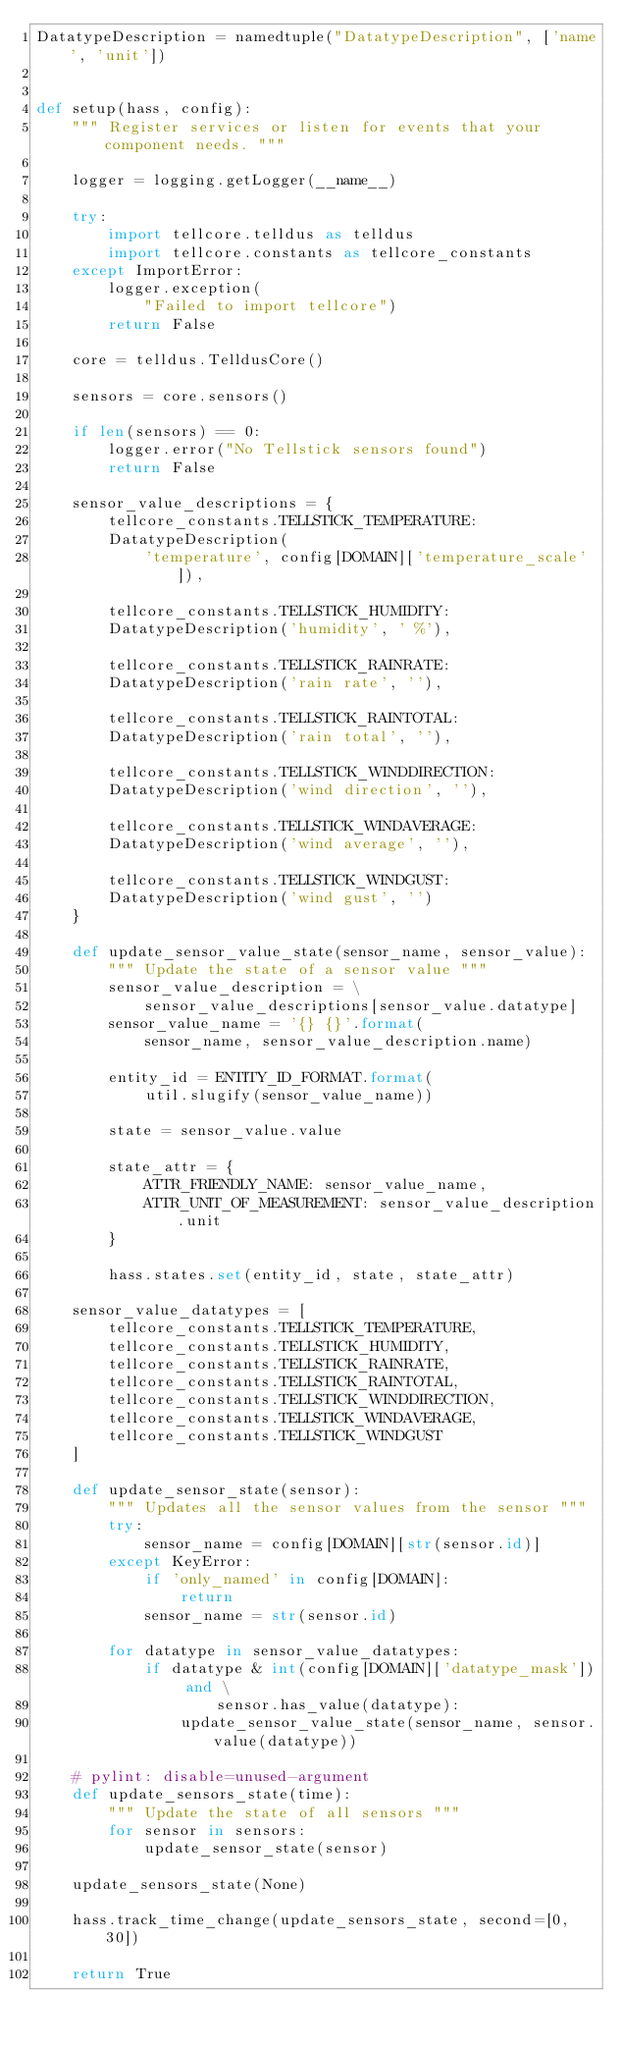<code> <loc_0><loc_0><loc_500><loc_500><_Python_>DatatypeDescription = namedtuple("DatatypeDescription", ['name', 'unit'])


def setup(hass, config):
    """ Register services or listen for events that your component needs. """

    logger = logging.getLogger(__name__)

    try:
        import tellcore.telldus as telldus
        import tellcore.constants as tellcore_constants
    except ImportError:
        logger.exception(
            "Failed to import tellcore")
        return False

    core = telldus.TelldusCore()

    sensors = core.sensors()

    if len(sensors) == 0:
        logger.error("No Tellstick sensors found")
        return False

    sensor_value_descriptions = {
        tellcore_constants.TELLSTICK_TEMPERATURE:
        DatatypeDescription(
            'temperature', config[DOMAIN]['temperature_scale']),

        tellcore_constants.TELLSTICK_HUMIDITY:
        DatatypeDescription('humidity', ' %'),

        tellcore_constants.TELLSTICK_RAINRATE:
        DatatypeDescription('rain rate', ''),

        tellcore_constants.TELLSTICK_RAINTOTAL:
        DatatypeDescription('rain total', ''),

        tellcore_constants.TELLSTICK_WINDDIRECTION:
        DatatypeDescription('wind direction', ''),

        tellcore_constants.TELLSTICK_WINDAVERAGE:
        DatatypeDescription('wind average', ''),

        tellcore_constants.TELLSTICK_WINDGUST:
        DatatypeDescription('wind gust', '')
    }

    def update_sensor_value_state(sensor_name, sensor_value):
        """ Update the state of a sensor value """
        sensor_value_description = \
            sensor_value_descriptions[sensor_value.datatype]
        sensor_value_name = '{} {}'.format(
            sensor_name, sensor_value_description.name)

        entity_id = ENTITY_ID_FORMAT.format(
            util.slugify(sensor_value_name))

        state = sensor_value.value

        state_attr = {
            ATTR_FRIENDLY_NAME: sensor_value_name,
            ATTR_UNIT_OF_MEASUREMENT: sensor_value_description.unit
        }

        hass.states.set(entity_id, state, state_attr)

    sensor_value_datatypes = [
        tellcore_constants.TELLSTICK_TEMPERATURE,
        tellcore_constants.TELLSTICK_HUMIDITY,
        tellcore_constants.TELLSTICK_RAINRATE,
        tellcore_constants.TELLSTICK_RAINTOTAL,
        tellcore_constants.TELLSTICK_WINDDIRECTION,
        tellcore_constants.TELLSTICK_WINDAVERAGE,
        tellcore_constants.TELLSTICK_WINDGUST
    ]

    def update_sensor_state(sensor):
        """ Updates all the sensor values from the sensor """
        try:
            sensor_name = config[DOMAIN][str(sensor.id)]
        except KeyError:
            if 'only_named' in config[DOMAIN]:
                return
            sensor_name = str(sensor.id)

        for datatype in sensor_value_datatypes:
            if datatype & int(config[DOMAIN]['datatype_mask']) and \
                    sensor.has_value(datatype):
                update_sensor_value_state(sensor_name, sensor.value(datatype))

    # pylint: disable=unused-argument
    def update_sensors_state(time):
        """ Update the state of all sensors """
        for sensor in sensors:
            update_sensor_state(sensor)

    update_sensors_state(None)

    hass.track_time_change(update_sensors_state, second=[0, 30])

    return True
</code> 